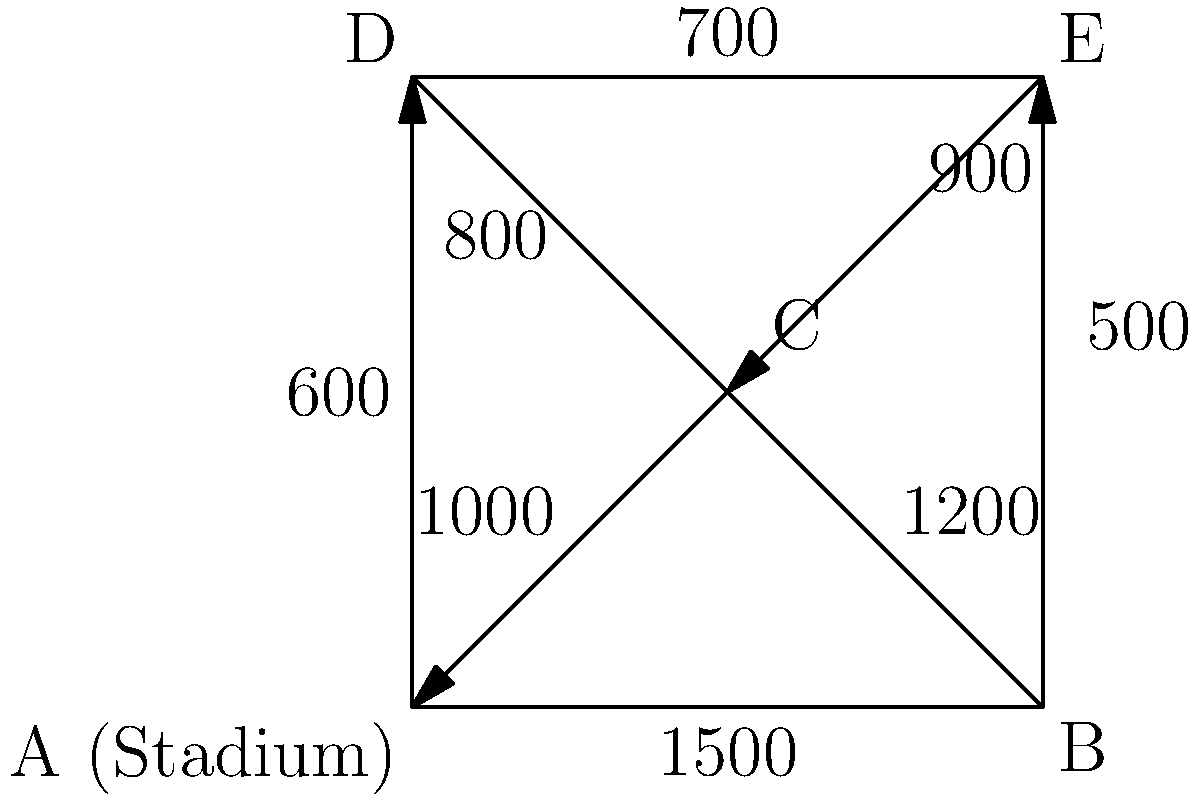As a Tampa Bay Rays fan, you're concerned about traffic flow around the new stadium. The city planners have provided a road network diagram showing the maximum vehicle capacity per hour for each road segment. What is the maximum number of vehicles that can leave the stadium (node A) per hour according to the Ford-Fulkerson algorithm? To solve this problem, we'll use the Ford-Fulkerson algorithm to find the maximum flow from the source (stadium, node A) to all other nodes. Here's the step-by-step process:

1. Identify all possible paths from A to other nodes:
   Path 1: A → B
   Path 2: A → C
   Path 3: A → D
   Path 4: A → C → D
   Path 5: A → C → E
   Path 6: A → B → C → D
   Path 7: A → B → C → E

2. Start with zero flow and iteratively increase the flow along each path:

   Path 1: A → B (1500 vehicles)
   Total flow: 1500

   Path 2: A → C (1000 vehicles)
   Total flow: 2500

   Path 3: A → D (600 vehicles)
   Total flow: 3100

   Path 4: A → C → D
   Remaining capacity on A → C: 0
   No additional flow

   Path 5: A → C → E
   Remaining capacity on A → C: 0
   No additional flow

   Path 6: A → B → C → D
   Remaining capacity on A → B: 0
   No additional flow

   Path 7: A → B → C → E
   Remaining capacity on A → B: 0
   No additional flow

3. The maximum flow is achieved when no more paths with available capacity can be found.

Therefore, the maximum number of vehicles that can leave the stadium (node A) per hour is 3100.
Answer: 3100 vehicles per hour 